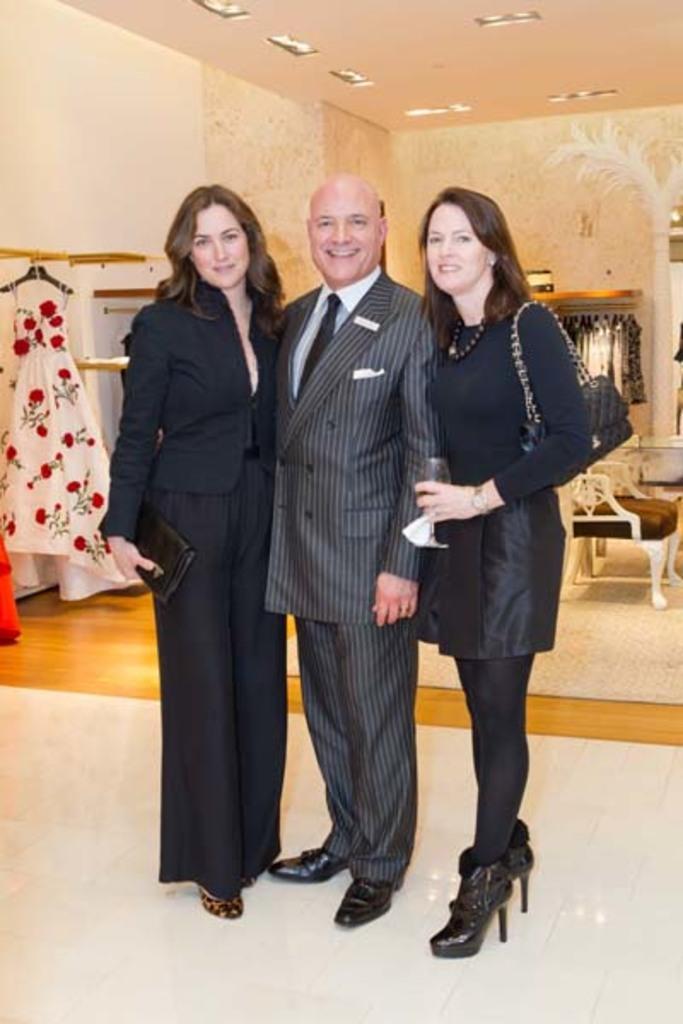Describe this image in one or two sentences. In this picture we can see a man and two women standing on the floor and smiling and in the background we can see clothes, chair, wall, lights. 